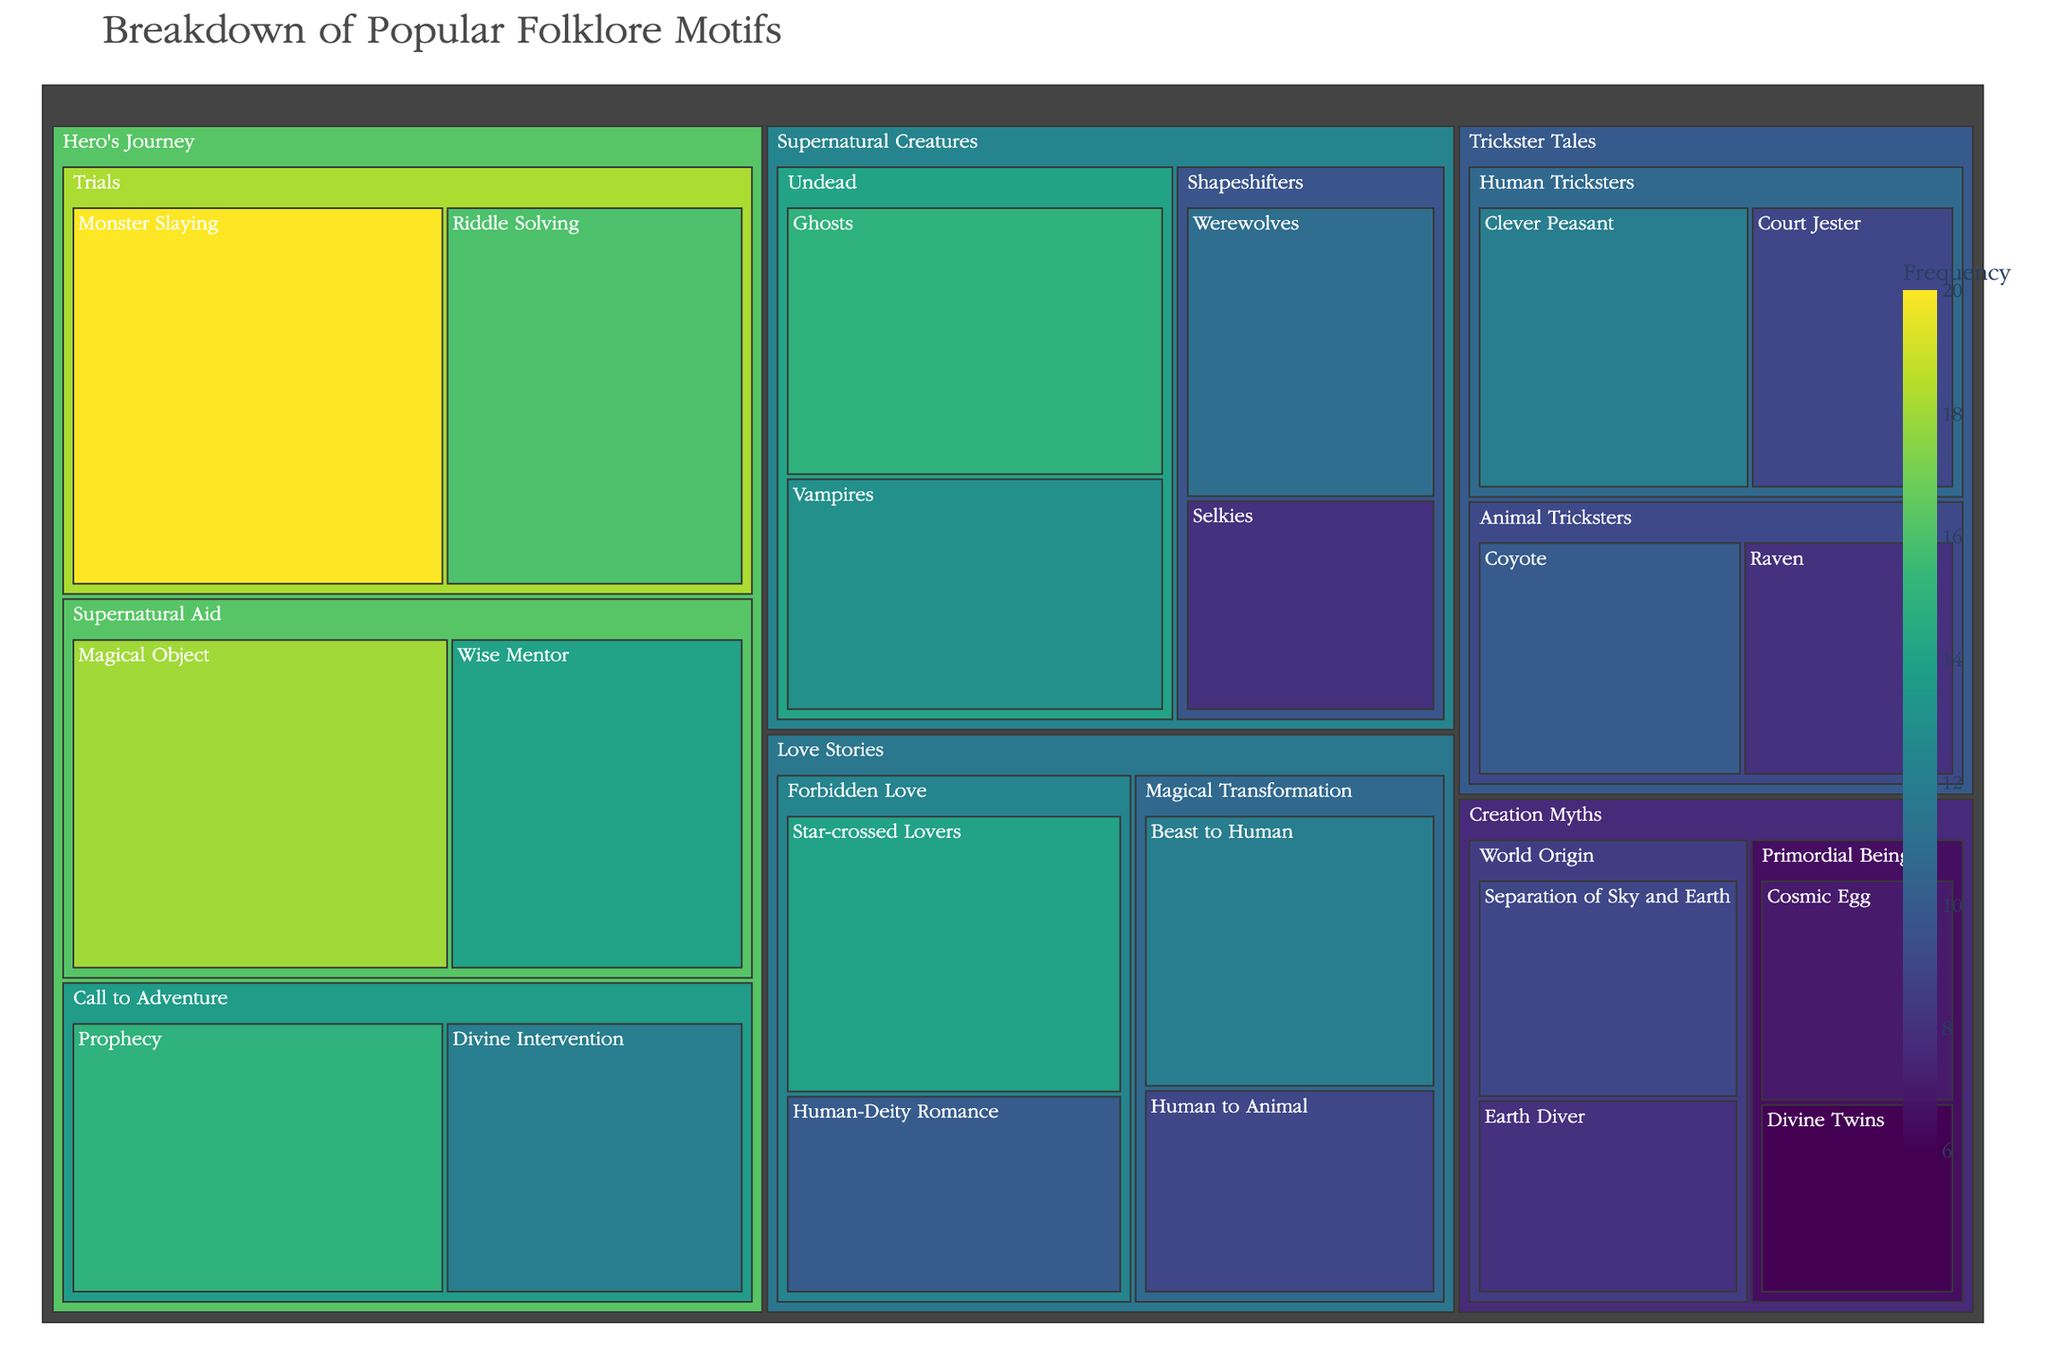What is the title of the figure? The title is usually prominently displayed at the top of the figure and describes the content of the treemap.
Answer: Breakdown of Popular Folklore Motifs Which motif under the 'Hero's Journey' category has the highest value? Identify the largest rectangle within the 'Hero's Journey' category by its visual size. The one with the largest dimensions represents the highest value.
Answer: Monster Slaying How many motifs are there in the 'Trickster Tales' category? Count the number of rectangular blocks within the 'Trickster Tales' section. Each block represents a motif.
Answer: 4 What is the combined value of all motifs in the 'Supernatural Creatures' category? Add the values of all motifs within the 'Supernatural Creatures' category: Werewolves (11) + Selkies (8) + Vampires (13) + Ghosts (15).
Answer: 47 Which motif has a higher value: 'Divine Intervention' or 'Clever Peasant'? Compare the values of 'Divine Intervention' from the 'Hero's Journey' category and 'Clever Peasant' from the 'Trickster Tales' category using the visual or numerical values.
Answer: Divine Intervention What is the difference in value between 'Star-crossed Lovers' and 'Human to Animal'? Subtract the value of 'Human to Animal' from the value of 'Star-crossed Lovers': 14 (Star-crossed Lovers) - 9 (Human to Animal).
Answer: 5 Which subcategory within 'Creation Myths' has a higher total value, 'Primordial Beings' or 'World Origin'? Sum the values of motifs in each subcategory and compare. Primordial Beings: (Cosmic Egg 7) + (Divine Twins 6) = 13; World Origin: (Earth Diver 8) + (Separation of Sky and Earth 9) = 17.
Answer: World Origin How many motifs in the overall data have a value greater than 10? Examine each motif's value and count the ones greater than 10.
Answer: 10 What is the smallest motif value in the figure, and which motif does it correspond to? Identify the smallest numerical value and locate the associated motif.
Answer: Divine Twins, 6 What is the average value of motifs in the 'Love Stories' category? Calculate the average by adding all values in 'Love Stories' and dividing by the number of motifs: (14 + 10 + 12 + 9) / 4.
Answer: 11.25 